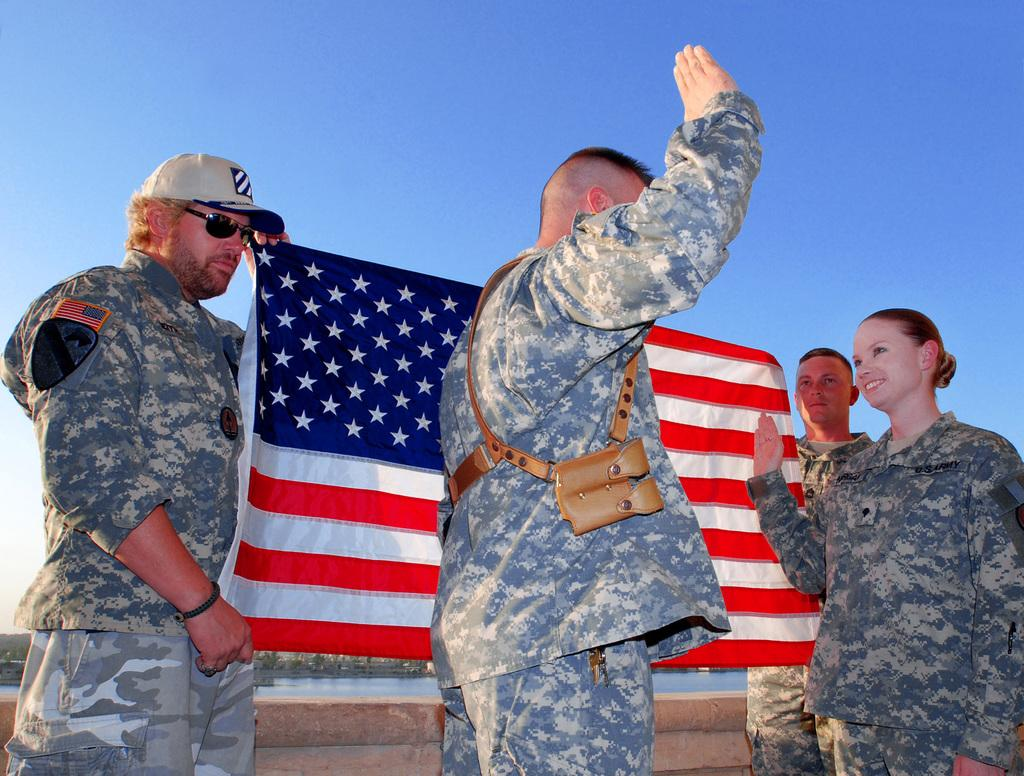What can be seen in the image? There is a group of people in the image. Can you describe the man on the left side of the image? The man on the left side of the image is wearing spectacles and a cap. What is the man holding in the image? The man is holding a flag. What type of camera is the man using to take pictures in the image? There is no camera present in the image, and the man is not taking pictures. 